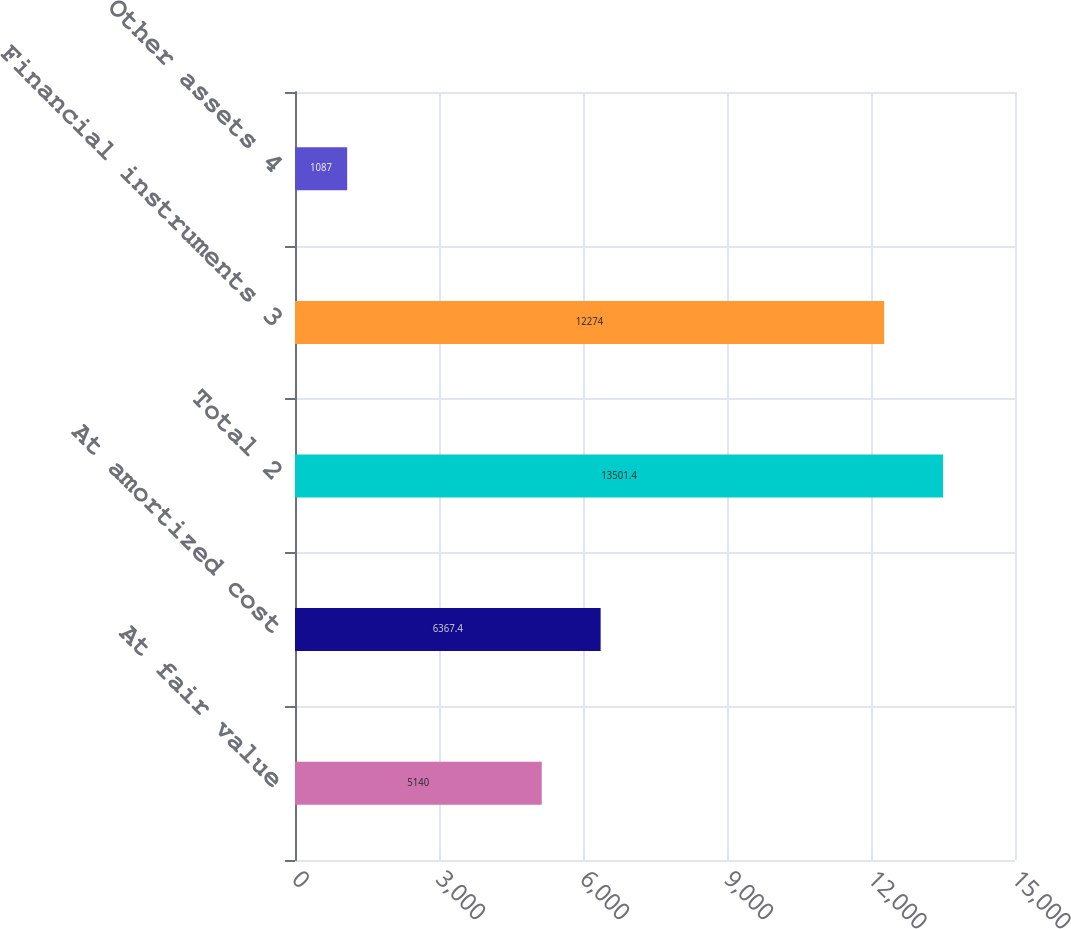Convert chart to OTSL. <chart><loc_0><loc_0><loc_500><loc_500><bar_chart><fcel>At fair value<fcel>At amortized cost<fcel>Total 2<fcel>Financial instruments 3<fcel>Other assets 4<nl><fcel>5140<fcel>6367.4<fcel>13501.4<fcel>12274<fcel>1087<nl></chart> 